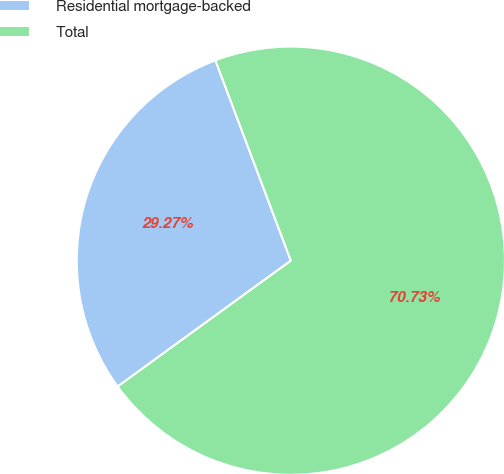Convert chart to OTSL. <chart><loc_0><loc_0><loc_500><loc_500><pie_chart><fcel>Residential mortgage-backed<fcel>Total<nl><fcel>29.27%<fcel>70.73%<nl></chart> 